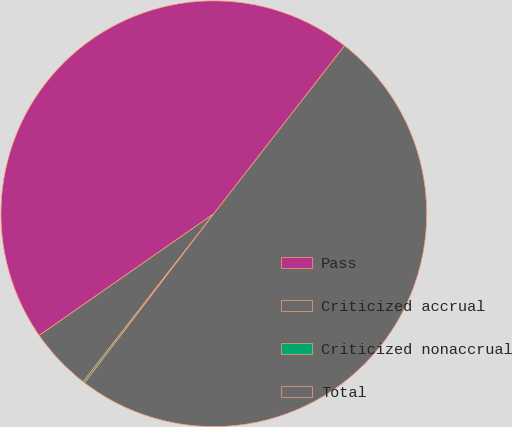Convert chart. <chart><loc_0><loc_0><loc_500><loc_500><pie_chart><fcel>Pass<fcel>Criticized accrual<fcel>Criticized nonaccrual<fcel>Total<nl><fcel>45.21%<fcel>4.79%<fcel>0.14%<fcel>49.86%<nl></chart> 